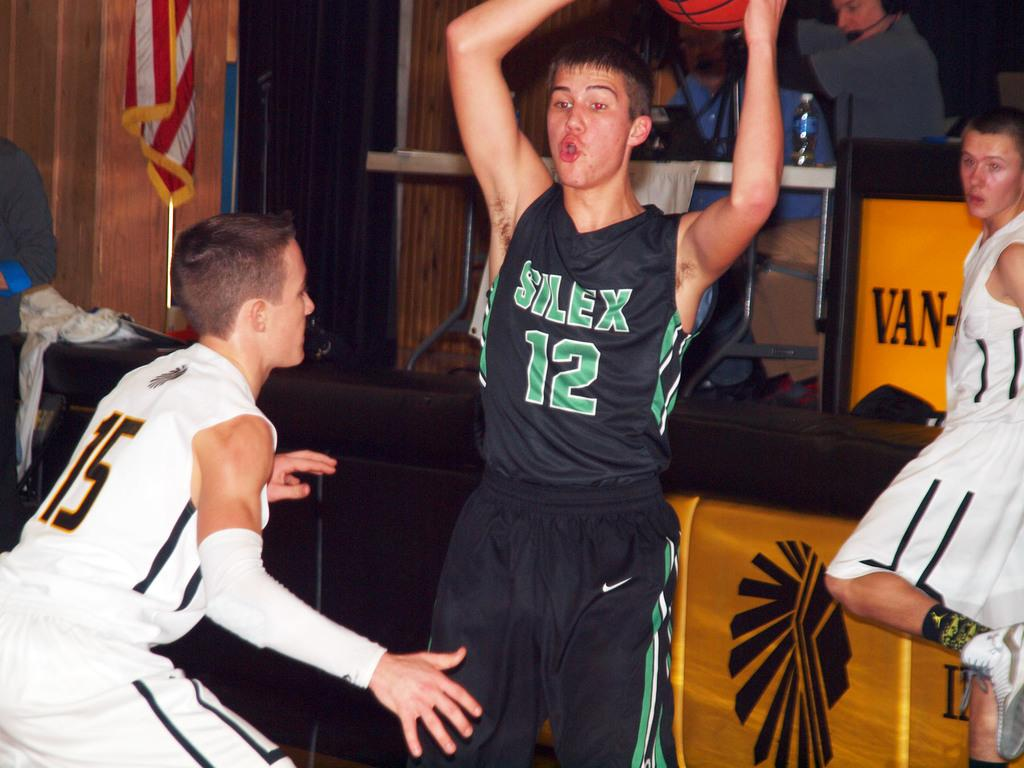<image>
Present a compact description of the photo's key features. Player number 12 holds the basketball over his head. 